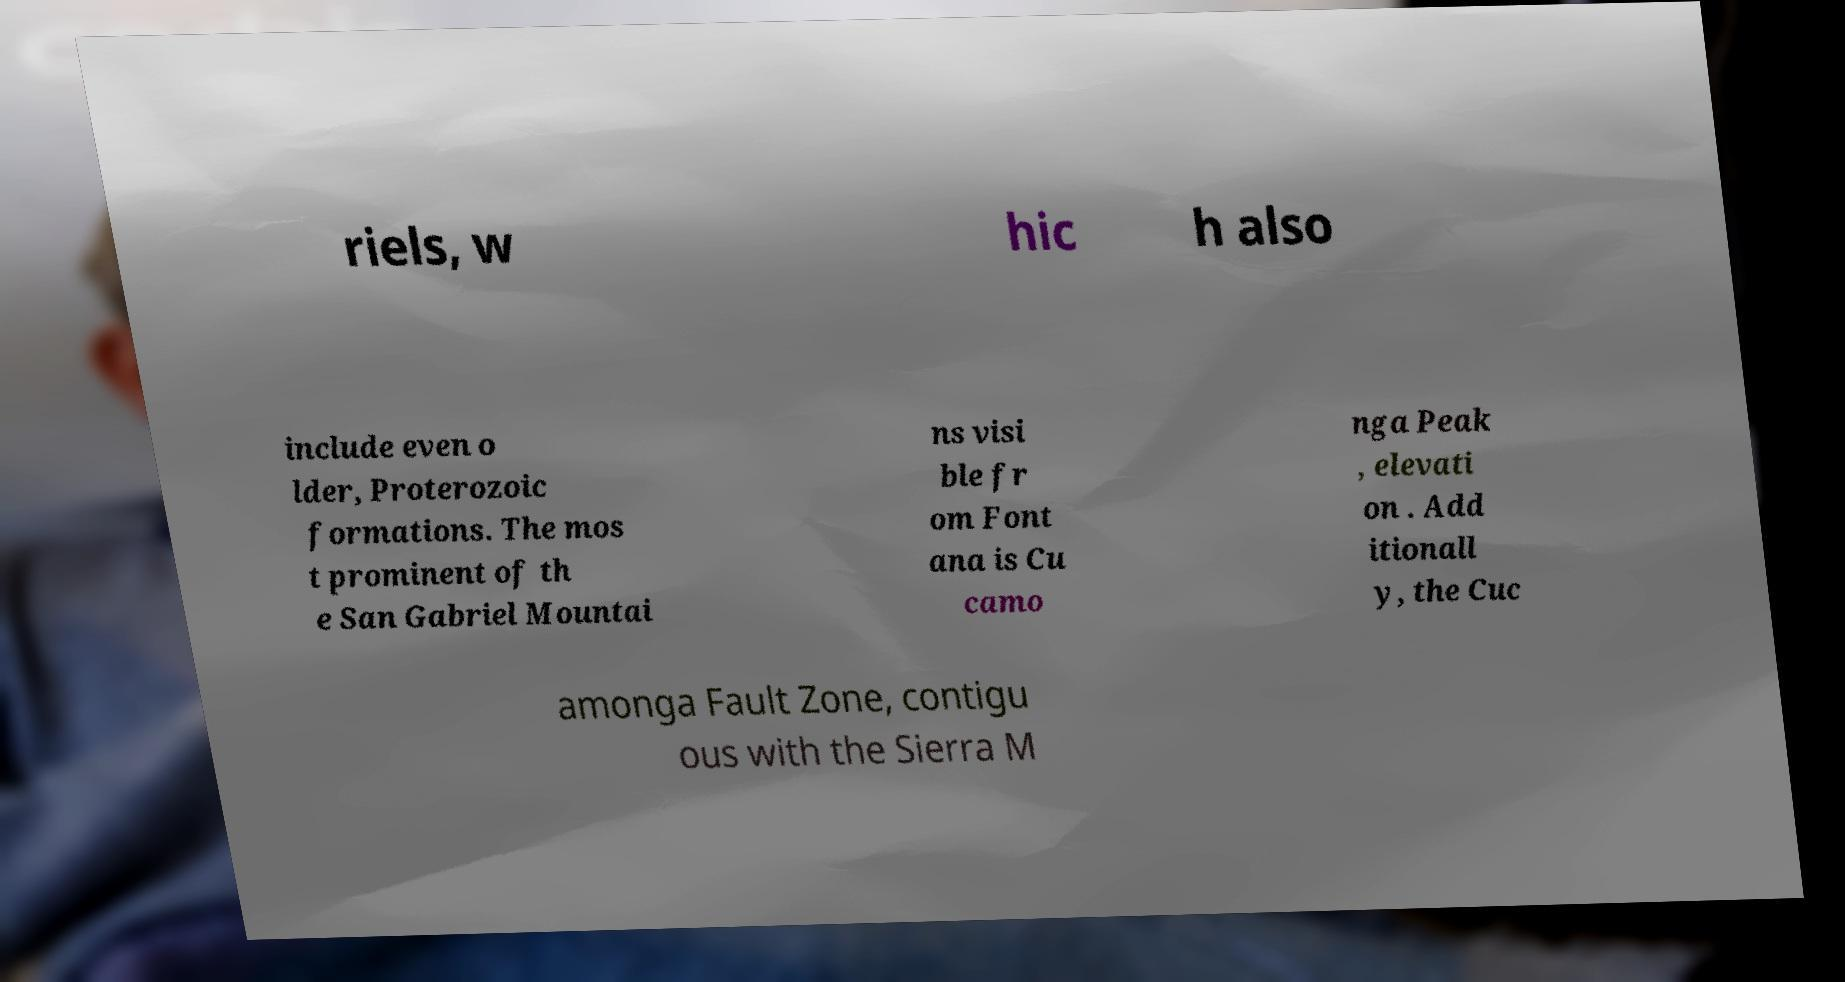There's text embedded in this image that I need extracted. Can you transcribe it verbatim? riels, w hic h also include even o lder, Proterozoic formations. The mos t prominent of th e San Gabriel Mountai ns visi ble fr om Font ana is Cu camo nga Peak , elevati on . Add itionall y, the Cuc amonga Fault Zone, contigu ous with the Sierra M 